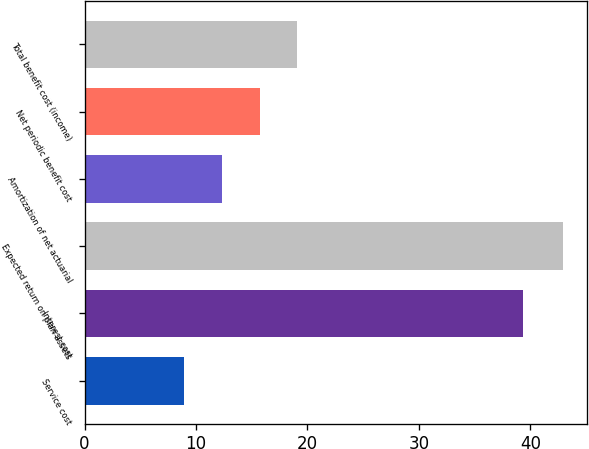Convert chart. <chart><loc_0><loc_0><loc_500><loc_500><bar_chart><fcel>Service cost<fcel>Interest cost<fcel>Expected return on plan assets<fcel>Amortization of net actuarial<fcel>Net periodic benefit cost<fcel>Total benefit cost (income)<nl><fcel>8.9<fcel>39.3<fcel>42.9<fcel>12.3<fcel>15.7<fcel>19.1<nl></chart> 